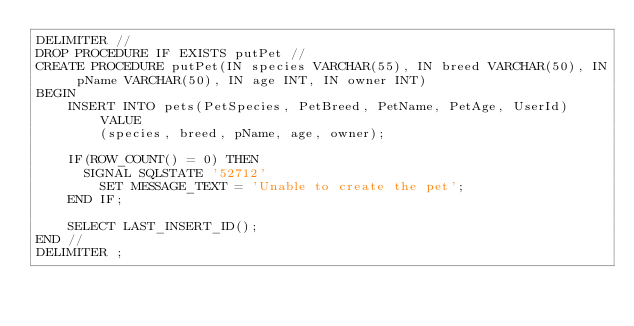Convert code to text. <code><loc_0><loc_0><loc_500><loc_500><_SQL_>DELIMITER //
DROP PROCEDURE IF EXISTS putPet //
CREATE PROCEDURE putPet(IN species VARCHAR(55), IN breed VARCHAR(50), IN pName VARCHAR(50), IN age INT, IN owner INT)
BEGIN   
    INSERT INTO pets(PetSpecies, PetBreed, PetName, PetAge, UserId) VALUE
        (species, breed, pName, age, owner);
    
    IF(ROW_COUNT() = 0) THEN
      SIGNAL SQLSTATE '52712'
        SET MESSAGE_TEXT = 'Unable to create the pet';
    END IF;

    SELECT LAST_INSERT_ID();
END //
DELIMITER ;
</code> 